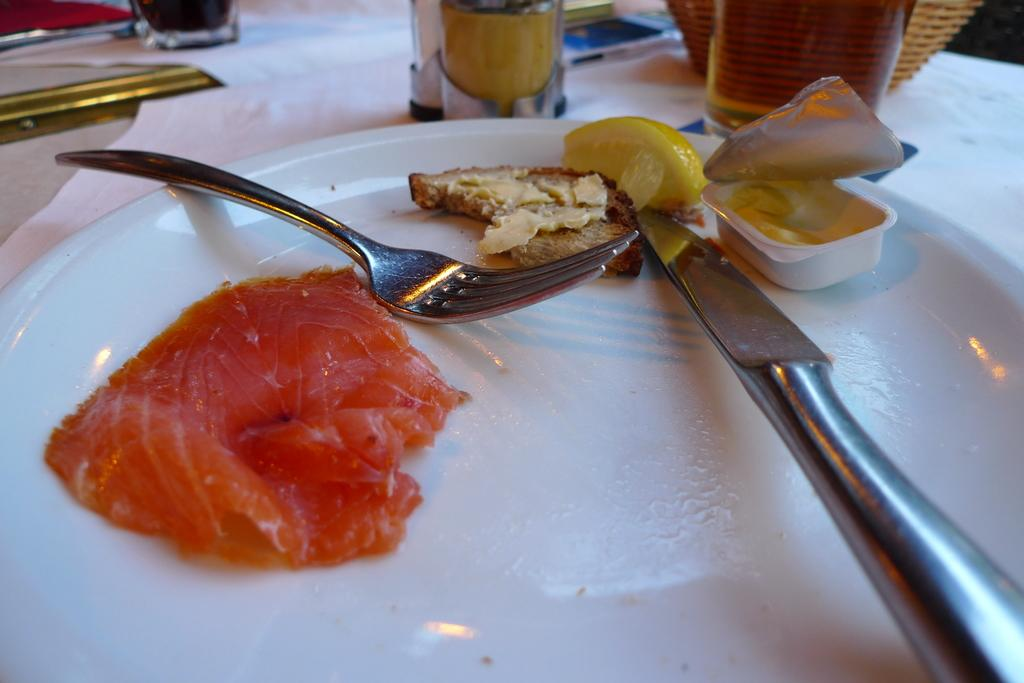What piece of furniture is present in the image? There is a table in the image. What objects are placed on the table? There are glasses and a plate on the table. What is on the plate? There are food items in the plate. How many deer can be seen sleeping on the table in the image? There are no deer present in the image, and they cannot sleep on the table as it is not a suitable surface for them. 